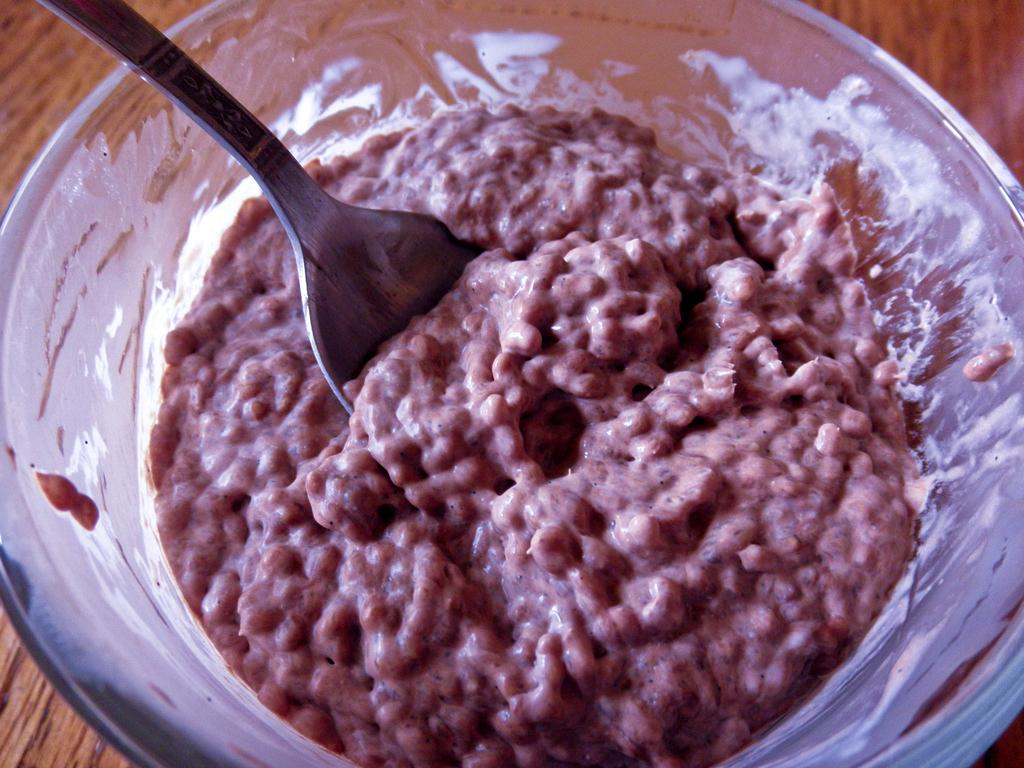What type of table is in the image? There is a wooden table in the image. What is on the table? There is food in a glass bowl on the table. What utensil is in the bowl? There is a spoon in the bowl. How does the airplane relate to the wooden table in the image? There is no airplane present in the image, so it does not relate to the wooden table. 